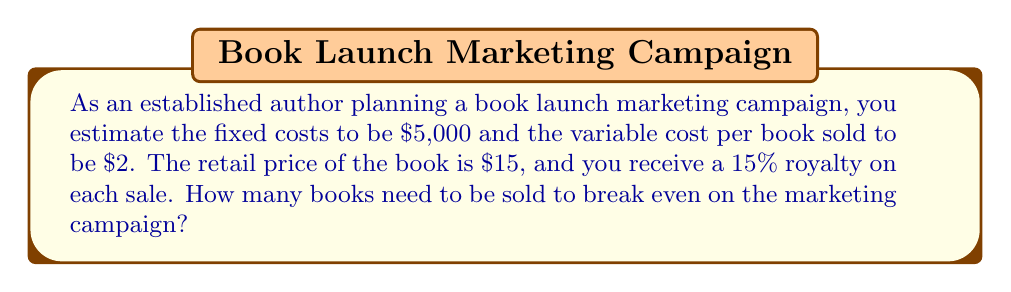What is the answer to this math problem? Let's approach this step-by-step using cost-benefit analysis:

1) First, let's define our variables:
   $x$ = number of books sold
   $F$ = fixed costs
   $v$ = variable cost per book
   $p$ = retail price per book
   $r$ = royalty rate

2) We know:
   $F = 5000$
   $v = 2$
   $p = 15$
   $r = 0.15$

3) The break-even point occurs when total costs equal total revenue:
   Total Costs = Total Revenue
   $F + vx = rpx$

4) Substituting our known values:
   $5000 + 2x = 0.15 * 15x$

5) Simplify the right side:
   $5000 + 2x = 2.25x$

6) Subtract $2x$ from both sides:
   $5000 = 0.25x$

7) Divide both sides by 0.25:
   $x = 5000 / 0.25 = 20000$

Therefore, 20,000 books need to be sold to break even on the marketing campaign.
Answer: 20,000 books 